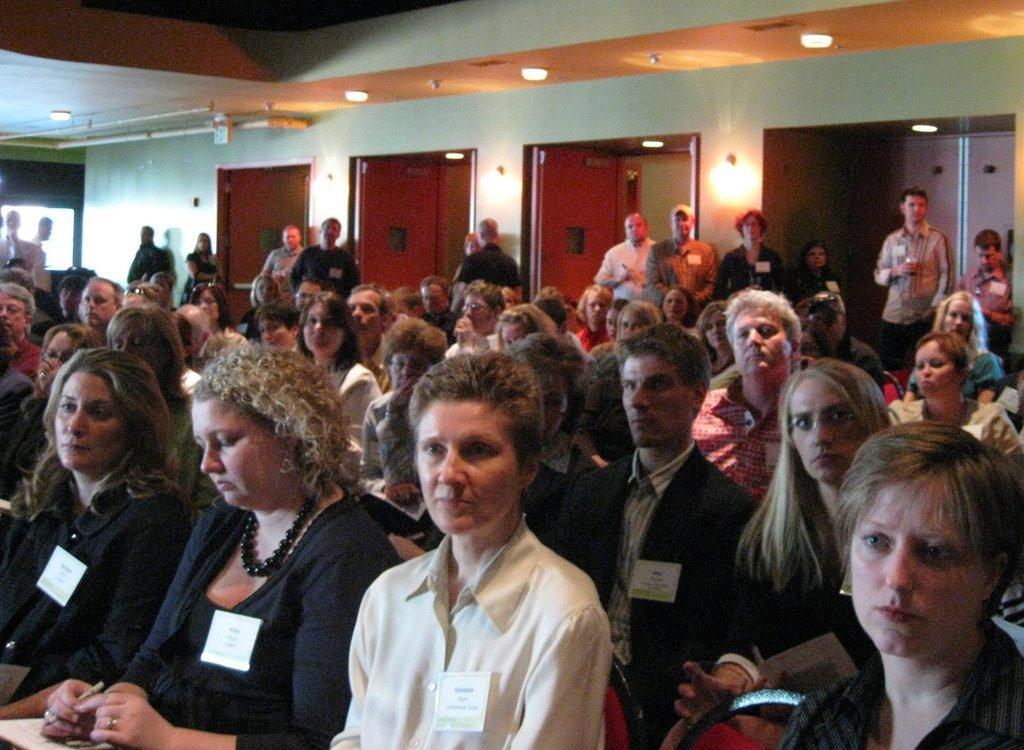Please provide a concise description of this image. In this image I can see number of people where few are standing and rest all are sitting. I can also see few lights and few doors. 